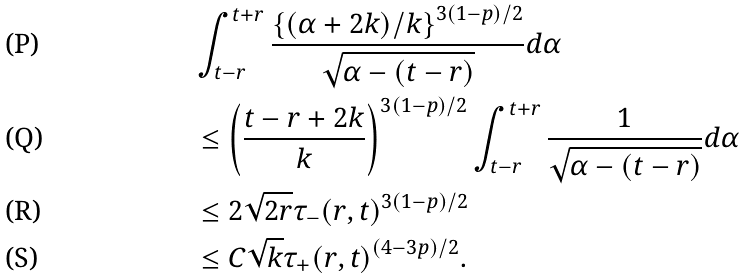<formula> <loc_0><loc_0><loc_500><loc_500>& \int _ { t - r } ^ { t + r } \frac { \left \{ ( \alpha + 2 k ) / k \right \} ^ { 3 ( 1 - p ) / 2 } } { \sqrt { \alpha - ( t - r ) } } d \alpha \\ & \leq \left ( \frac { t - r + 2 k } { k } \right ) ^ { 3 ( 1 - p ) / 2 } \int _ { t - r } ^ { t + r } \frac { 1 } { \sqrt { \alpha - ( t - r ) } } d \alpha \\ & \leq 2 \sqrt { 2 r } \tau _ { - } ( r , t ) ^ { 3 ( 1 - p ) / 2 } \\ & \leq C \sqrt { k } \tau _ { + } ( r , t ) ^ { ( 4 - 3 p ) / 2 } .</formula> 